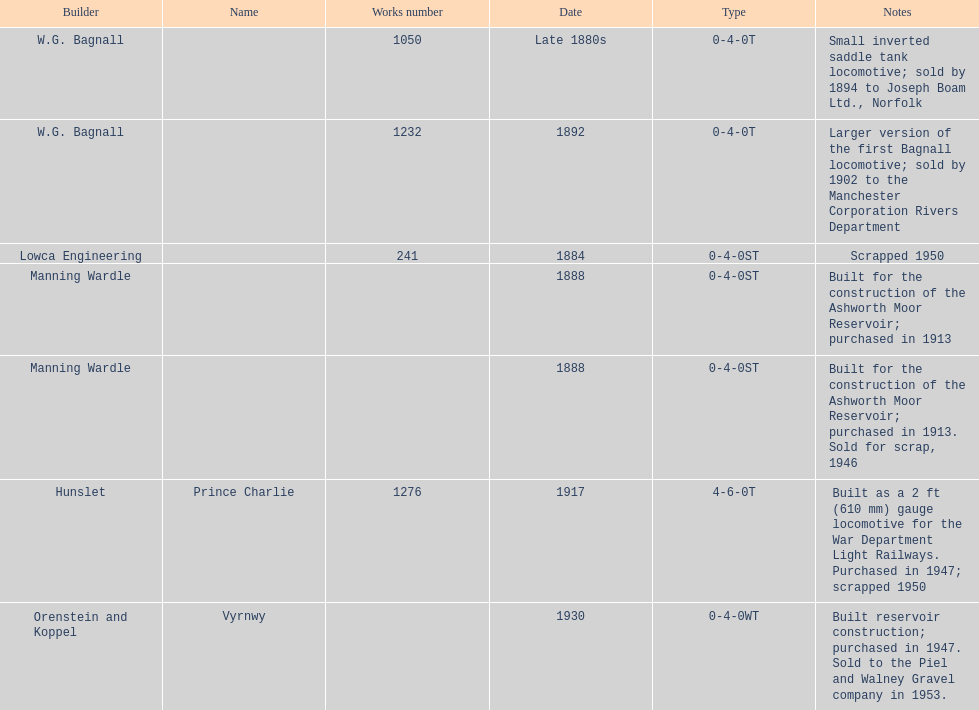List each of the builder's that had a locomotive scrapped. Lowca Engineering, Manning Wardle, Hunslet. 